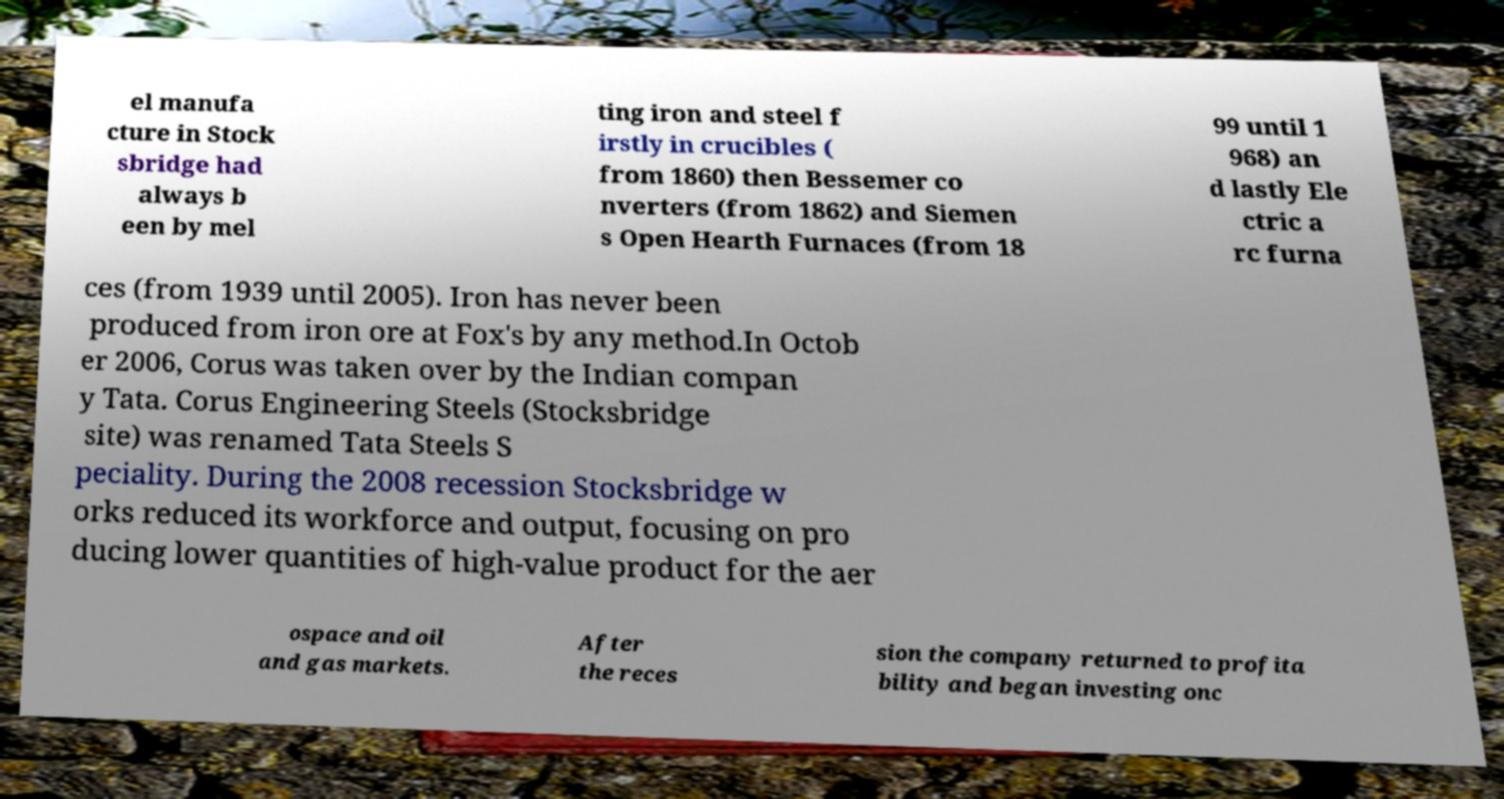I need the written content from this picture converted into text. Can you do that? el manufa cture in Stock sbridge had always b een by mel ting iron and steel f irstly in crucibles ( from 1860) then Bessemer co nverters (from 1862) and Siemen s Open Hearth Furnaces (from 18 99 until 1 968) an d lastly Ele ctric a rc furna ces (from 1939 until 2005). Iron has never been produced from iron ore at Fox's by any method.In Octob er 2006, Corus was taken over by the Indian compan y Tata. Corus Engineering Steels (Stocksbridge site) was renamed Tata Steels S peciality. During the 2008 recession Stocksbridge w orks reduced its workforce and output, focusing on pro ducing lower quantities of high-value product for the aer ospace and oil and gas markets. After the reces sion the company returned to profita bility and began investing onc 